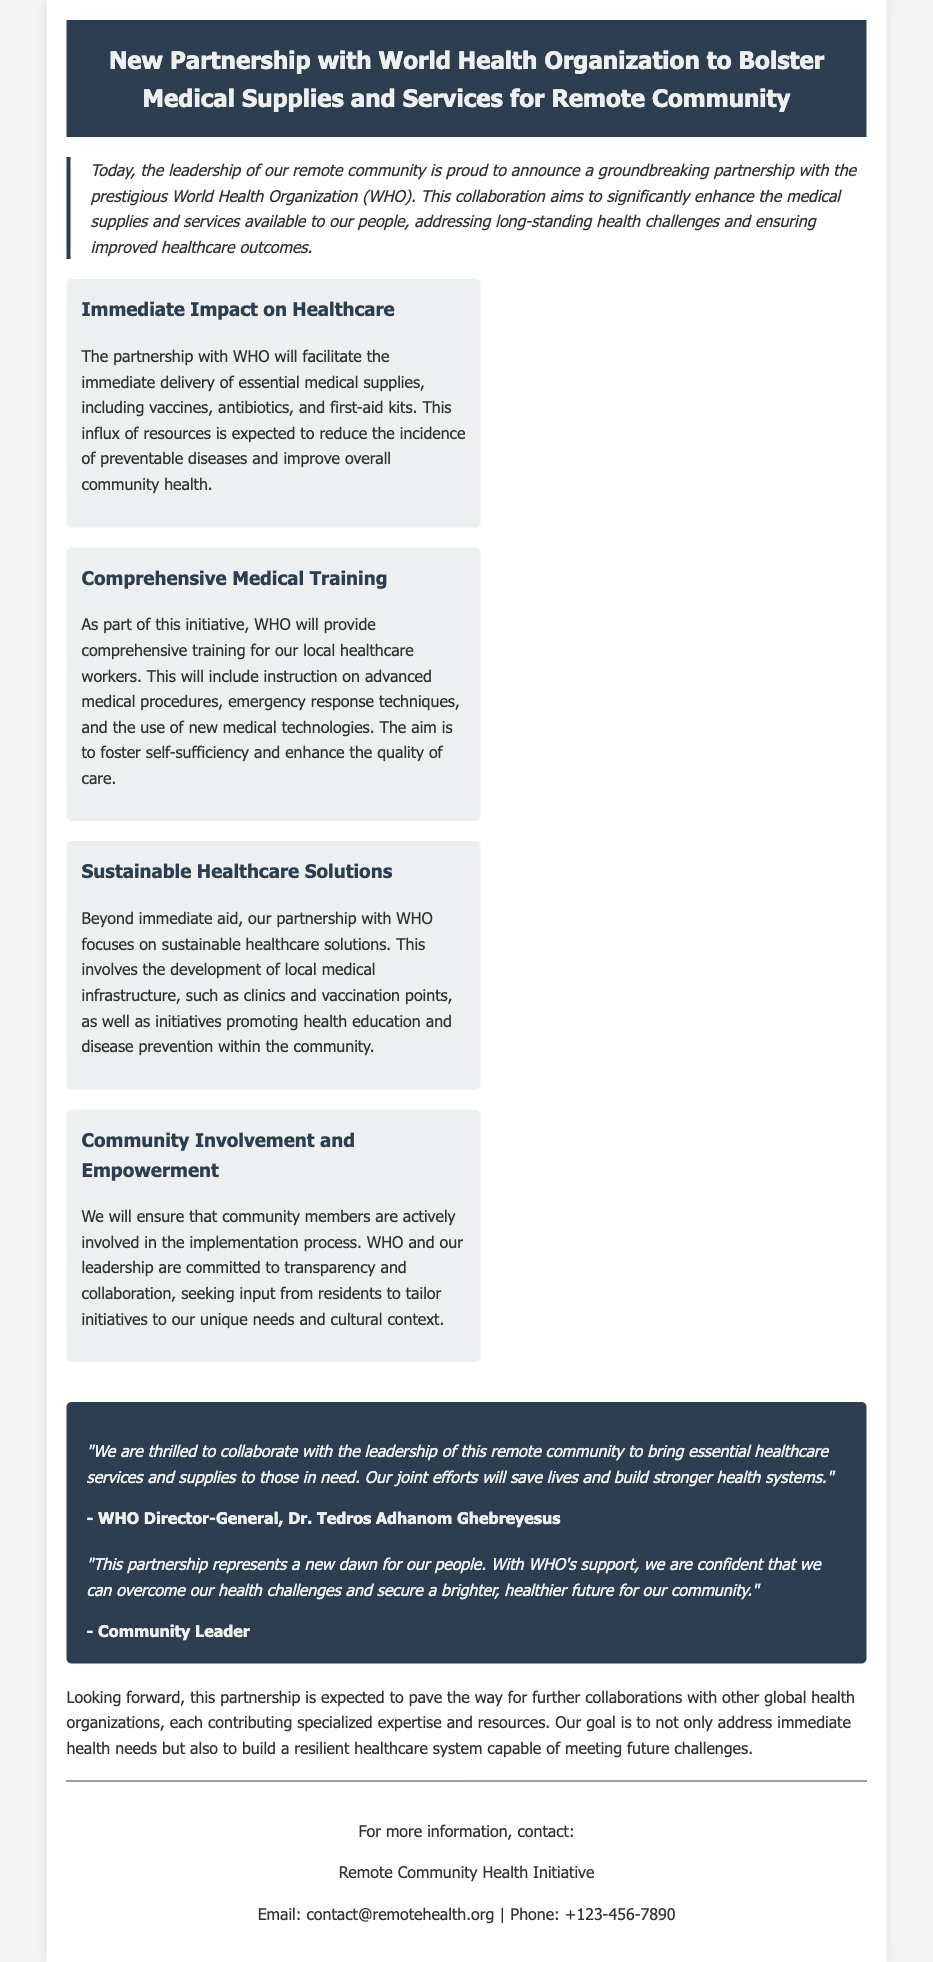What organization is partnering with the remote community? The press release states that the World Health Organization (WHO) is the partnering organization.
Answer: World Health Organization What type of training will WHO provide? The document mentions that WHO will provide comprehensive training for local healthcare workers, including instruction on advanced medical procedures.
Answer: Comprehensive training What immediate resources will be delivered as part of the partnership? The press release lists essential medical supplies including vaccines, antibiotics, and first-aid kits that will be delivered.
Answer: Vaccines, antibiotics, first-aid kits Who is quoted in the press release? The document includes quotes from the WHO Director-General and a community leader expressing their feelings about the partnership.
Answer: WHO Director-General, Community Leader What is the goal of the partnership beyond immediate aid? The partnership aims to build a resilient healthcare system capable of meeting future challenges, focusing on sustainable solutions.
Answer: Sustainable healthcare solutions How will community members be involved? The press release states that community members will be actively involved in the implementation process and decision-making.
Answer: Actively involved What aspect of healthcare does the partnership primarily focus on? The focus is primarily on enhancing medical supplies and services to address health challenges and improve outcomes.
Answer: Medical supplies and services What will happen to healthcare infrastructure as part of the initiative? The partnership involves the development of local medical infrastructure such as clinics and vaccination points.
Answer: Development of clinics and vaccination points 